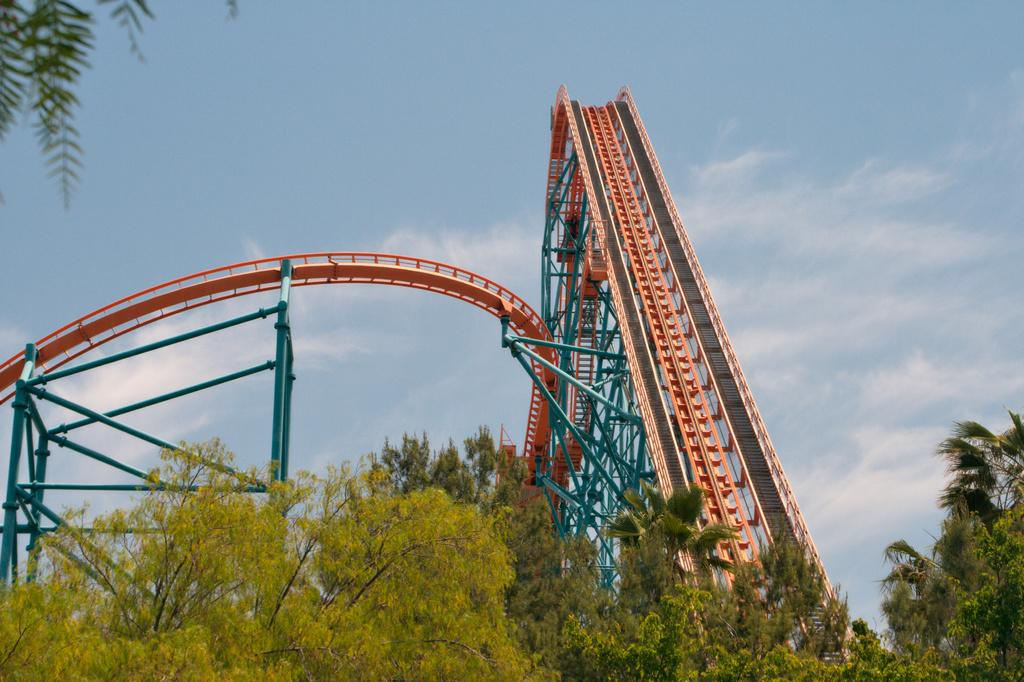What is the main feature of the image? There is a rollercoaster hump in the image. What else can be seen in the image besides the rollercoaster hump? There are poles and a group of trees in the foreground of the image. What is visible in the background of the image? The sky is visible in the background of the image. How would you describe the sky in the image? The sky appears to be cloudy. Can you hear any crimes being committed in the image? There is no indication of any crimes being committed in the image, and it is not possible to hear anything from a still image. 